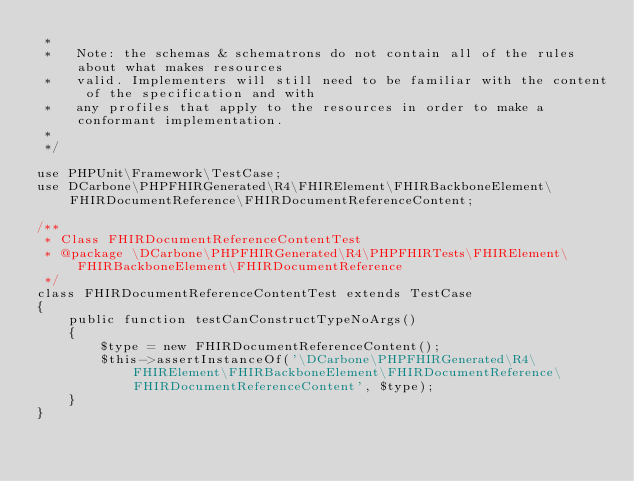<code> <loc_0><loc_0><loc_500><loc_500><_PHP_> * 
 *   Note: the schemas & schematrons do not contain all of the rules about what makes resources
 *   valid. Implementers will still need to be familiar with the content of the specification and with
 *   any profiles that apply to the resources in order to make a conformant implementation.
 * 
 */

use PHPUnit\Framework\TestCase;
use DCarbone\PHPFHIRGenerated\R4\FHIRElement\FHIRBackboneElement\FHIRDocumentReference\FHIRDocumentReferenceContent;

/**
 * Class FHIRDocumentReferenceContentTest
 * @package \DCarbone\PHPFHIRGenerated\R4\PHPFHIRTests\FHIRElement\FHIRBackboneElement\FHIRDocumentReference
 */
class FHIRDocumentReferenceContentTest extends TestCase
{
    public function testCanConstructTypeNoArgs()
    {
        $type = new FHIRDocumentReferenceContent();
        $this->assertInstanceOf('\DCarbone\PHPFHIRGenerated\R4\FHIRElement\FHIRBackboneElement\FHIRDocumentReference\FHIRDocumentReferenceContent', $type);
    }
}
</code> 